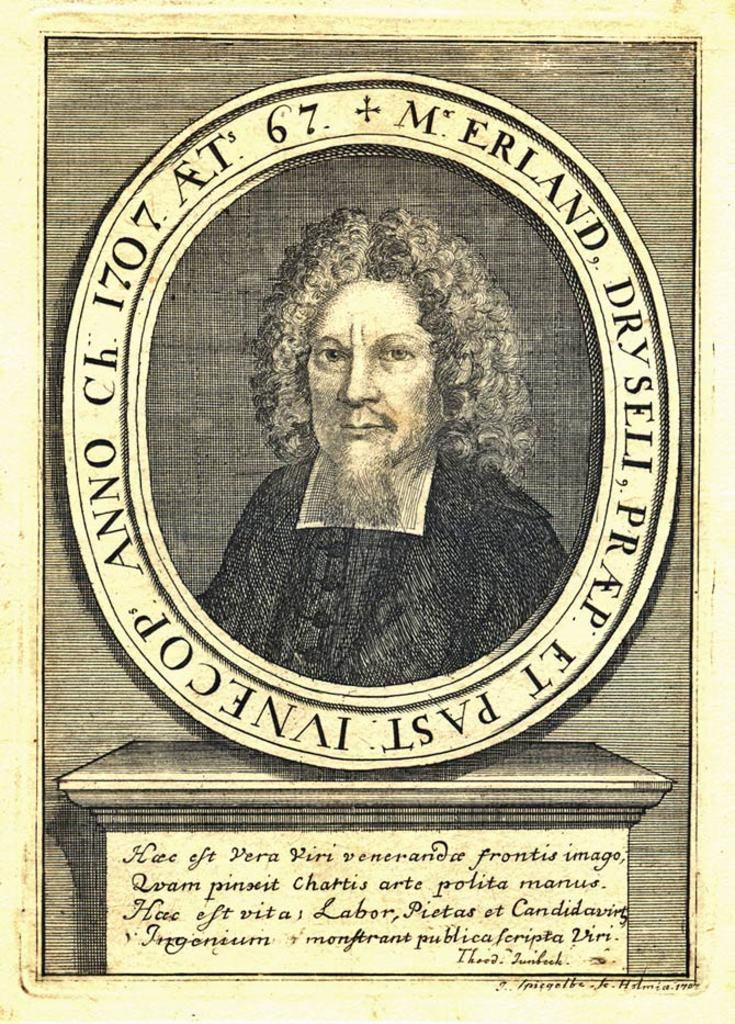What is present in the image related to a written document? There is a paper in the image. What is the purpose of the paper in the image? The paper contains a memorial of a person. What can be found on the paper besides the memorial? There is text on the paper. What type of waves can be seen crashing on the shore in the image? There are no waves or shore visible in the image; it only contains a paper with a memorial and text. 